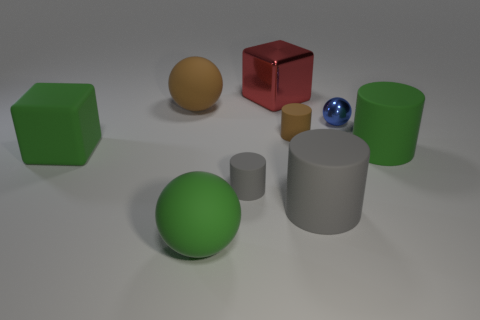There is a tiny thing that is in front of the object that is on the left side of the large sphere behind the small gray matte object; what shape is it?
Provide a short and direct response. Cylinder. There is a small gray matte cylinder; how many tiny rubber cylinders are behind it?
Your answer should be compact. 1. Are the large cube in front of the small sphere and the large brown sphere made of the same material?
Your answer should be compact. Yes. How many other things are the same shape as the red metallic object?
Offer a terse response. 1. There is a large matte sphere on the right side of the large matte ball behind the small brown cylinder; what number of brown spheres are in front of it?
Your answer should be very brief. 0. The big rubber ball in front of the tiny gray rubber cylinder is what color?
Make the answer very short. Green. There is a small rubber cylinder in front of the small brown object; does it have the same color as the large metal thing?
Your answer should be very brief. No. The brown thing that is the same shape as the tiny gray thing is what size?
Give a very brief answer. Small. What material is the large cube that is behind the brown rubber object that is left of the large sphere that is in front of the big green cylinder made of?
Provide a succinct answer. Metal. Is the number of large matte objects that are to the right of the small gray rubber cylinder greater than the number of large red cubes right of the red cube?
Make the answer very short. Yes. 